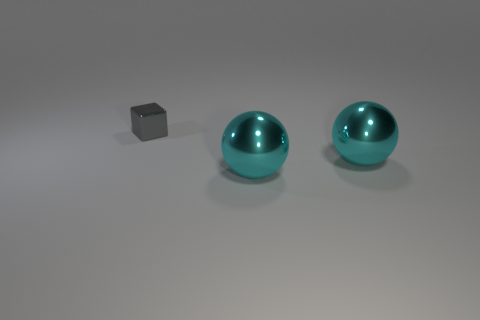What size is the gray block?
Provide a succinct answer. Small. How many cyan spheres are the same size as the gray shiny block?
Give a very brief answer. 0. How many other metallic things are the same shape as the gray metal thing?
Your answer should be compact. 0. Are there any spheres left of the metal cube?
Offer a terse response. No. How many matte objects are balls or small blocks?
Your answer should be very brief. 0. Is there anything else that has the same color as the tiny shiny cube?
Ensure brevity in your answer.  No. What number of other objects are there of the same size as the gray metal block?
Provide a succinct answer. 0. Is the number of big metallic things that are in front of the gray shiny cube greater than the number of gray metallic objects?
Your answer should be very brief. Yes. Is there a big cyan shiny cylinder?
Give a very brief answer. No. What number of other things are the same shape as the gray thing?
Provide a succinct answer. 0. 